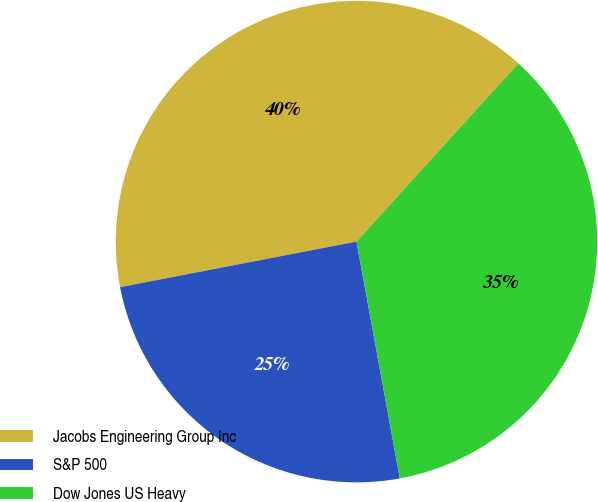Convert chart. <chart><loc_0><loc_0><loc_500><loc_500><pie_chart><fcel>Jacobs Engineering Group Inc<fcel>S&P 500<fcel>Dow Jones US Heavy<nl><fcel>39.76%<fcel>24.85%<fcel>35.39%<nl></chart> 